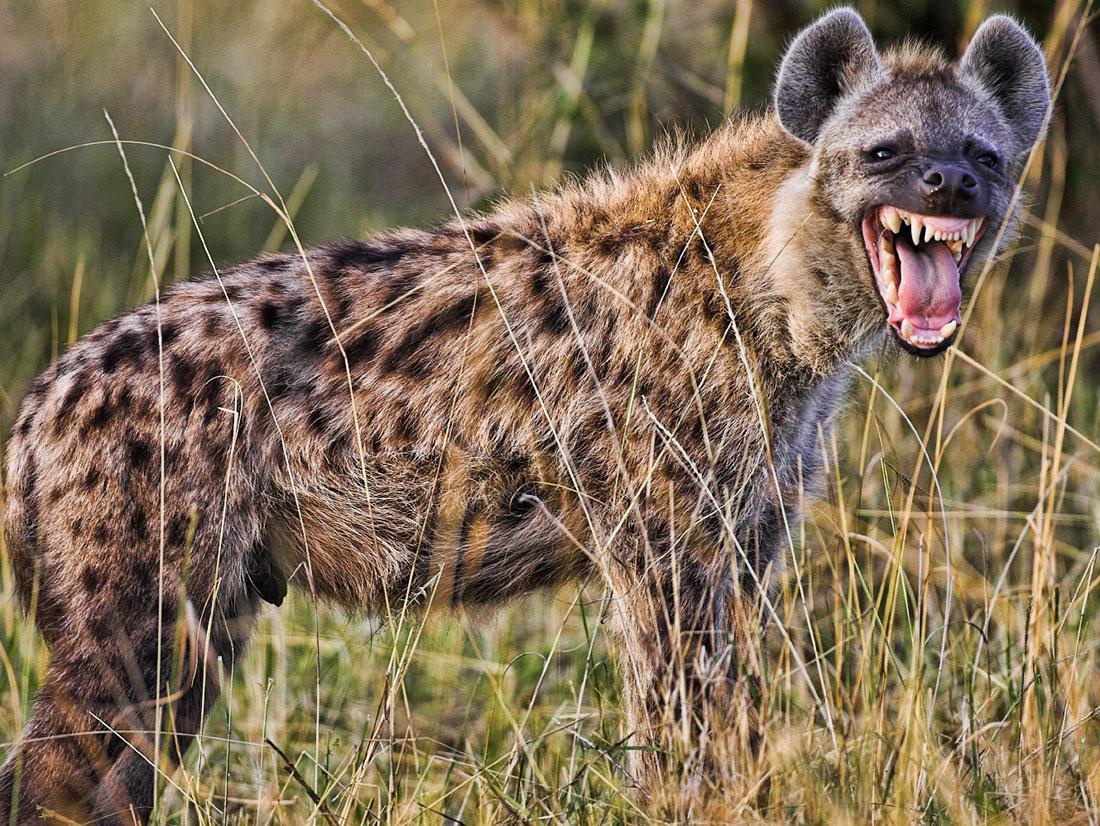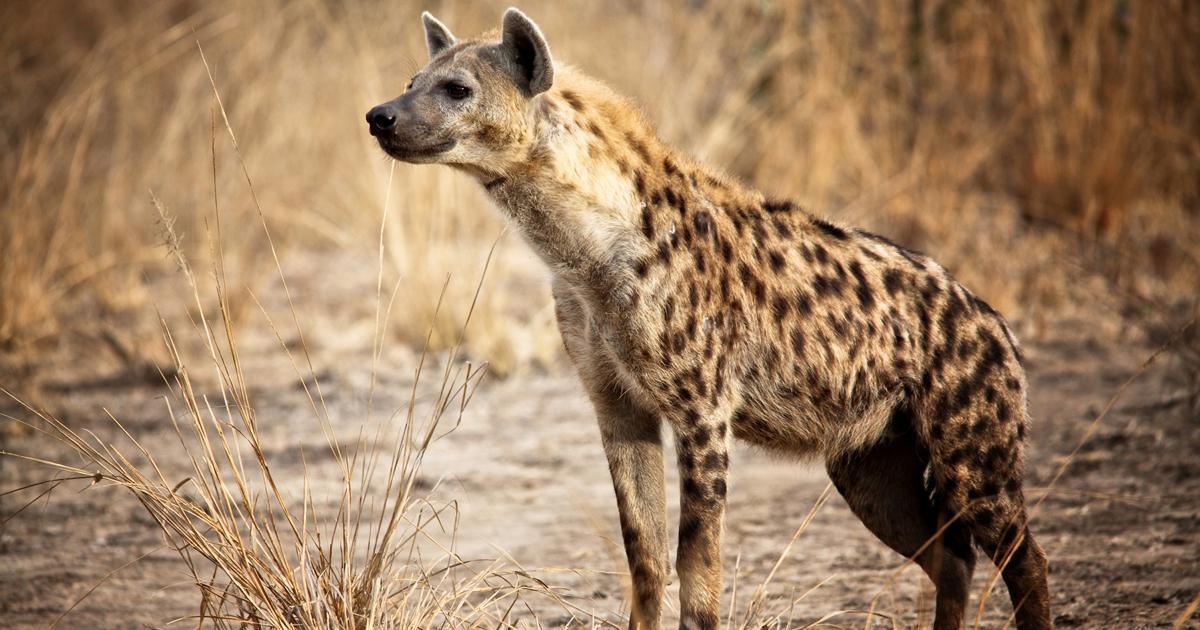The first image is the image on the left, the second image is the image on the right. For the images shown, is this caption "The hyena in the right image is baring its teeth." true? Answer yes or no. No. 